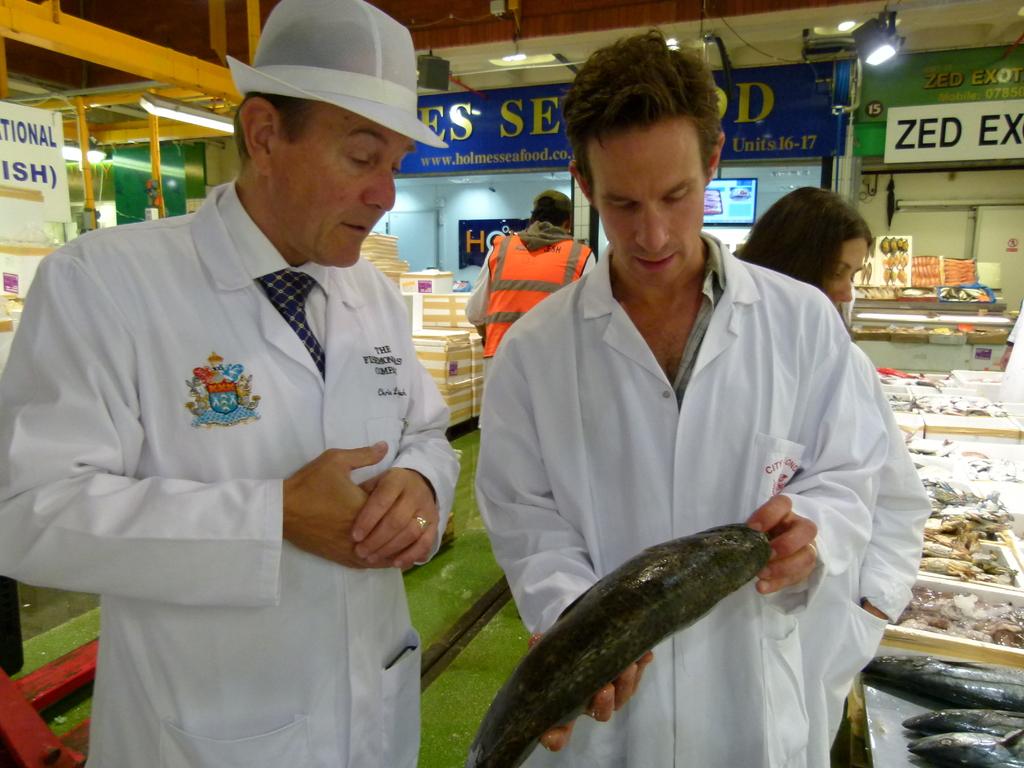Is the word "zed" visible in this photo?
Keep it short and to the point. Yes. 